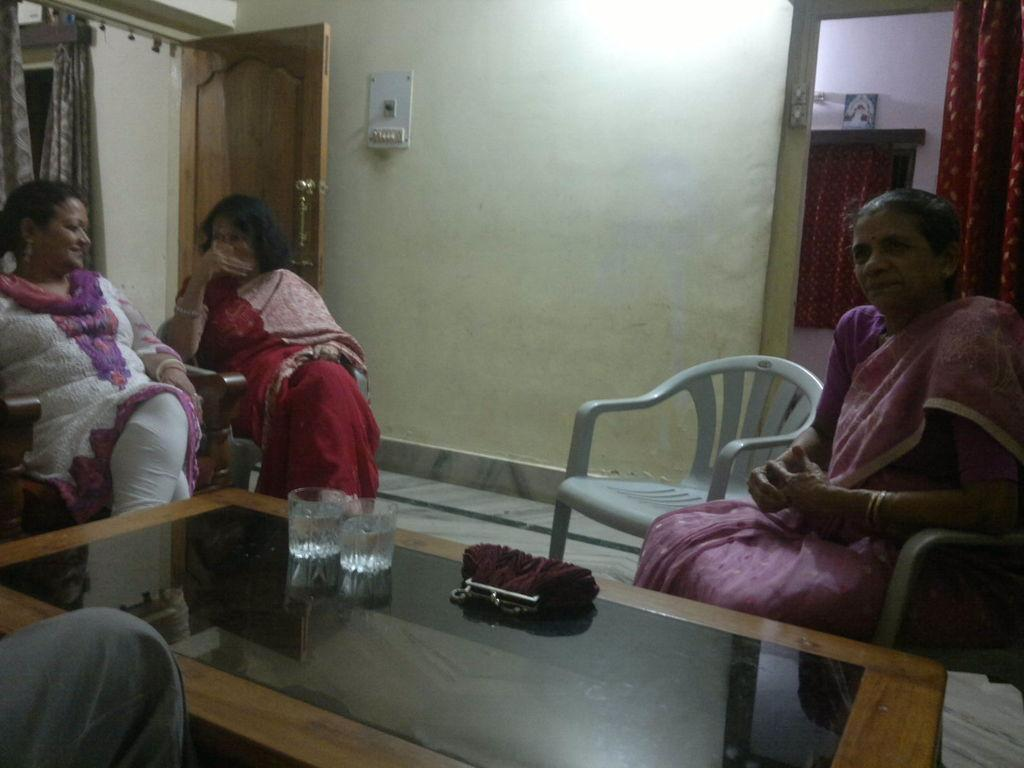Who is present in the image? There are women in the image. What are the women doing in the image? The women are sitting on chairs. What can be seen on the table in the image? There is a purse and two glasses of water on the table. What type of tree is growing in the middle of the table? There is no tree present on the table in the image. How many pins are visible on the women's clothing? The image does not provide enough detail to determine if there are any pins on the women's clothing. 